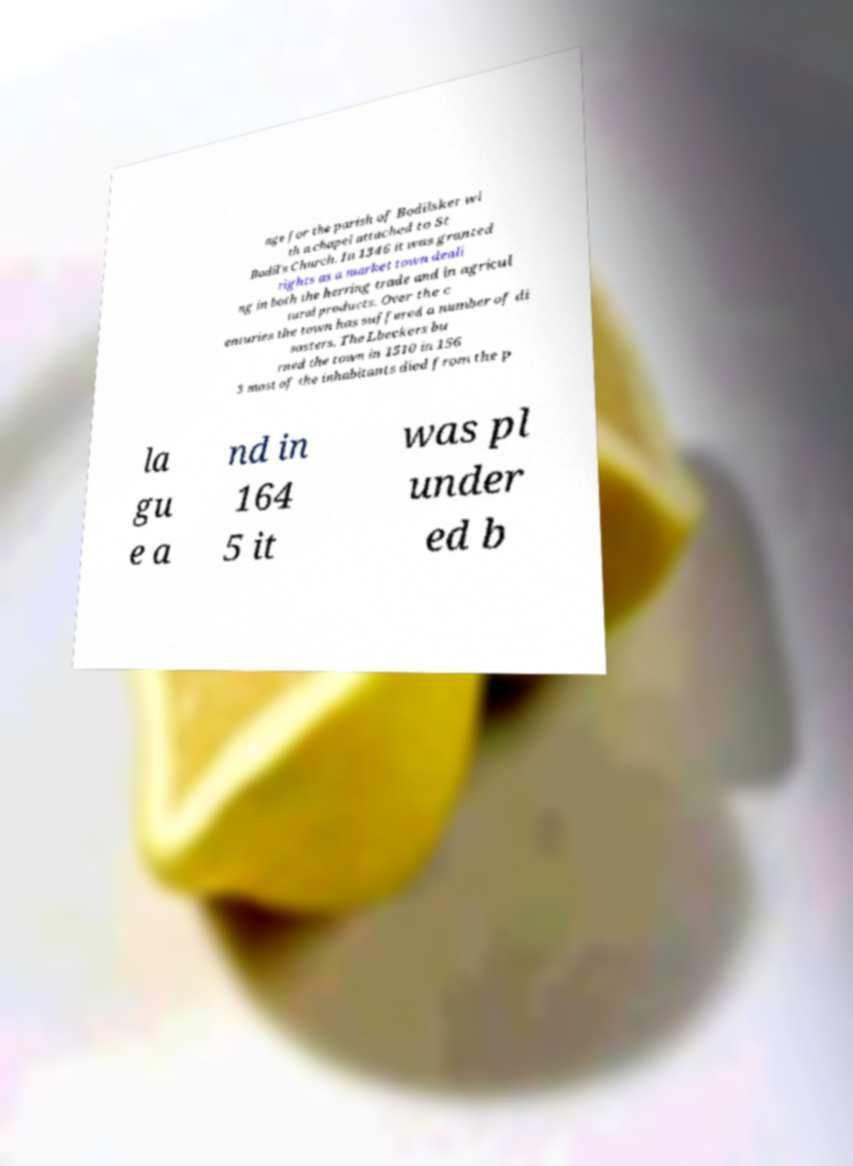Could you assist in decoding the text presented in this image and type it out clearly? age for the parish of Bodilsker wi th a chapel attached to St Bodil's Church. In 1346 it was granted rights as a market town deali ng in both the herring trade and in agricul tural products. Over the c enturies the town has suffered a number of di sasters. The Lbeckers bu rned the town in 1510 in 156 3 most of the inhabitants died from the p la gu e a nd in 164 5 it was pl under ed b 